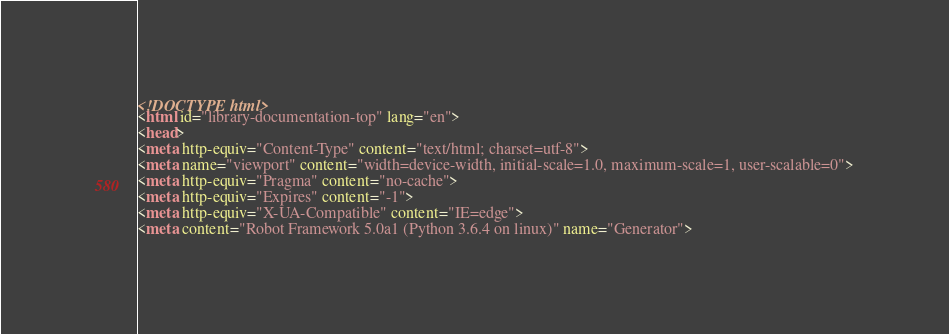<code> <loc_0><loc_0><loc_500><loc_500><_HTML_><!DOCTYPE html>
<html id="library-documentation-top" lang="en">
<head>
<meta http-equiv="Content-Type" content="text/html; charset=utf-8">
<meta name="viewport" content="width=device-width, initial-scale=1.0, maximum-scale=1, user-scalable=0">
<meta http-equiv="Pragma" content="no-cache">
<meta http-equiv="Expires" content="-1">
<meta http-equiv="X-UA-Compatible" content="IE=edge">
<meta content="Robot Framework 5.0a1 (Python 3.6.4 on linux)" name="Generator"></code> 